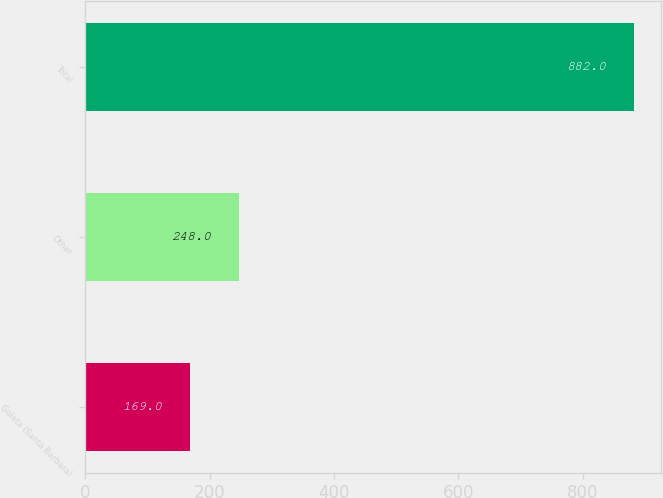<chart> <loc_0><loc_0><loc_500><loc_500><bar_chart><fcel>Goleta (Santa Barbara)<fcel>Other<fcel>Total<nl><fcel>169<fcel>248<fcel>882<nl></chart> 